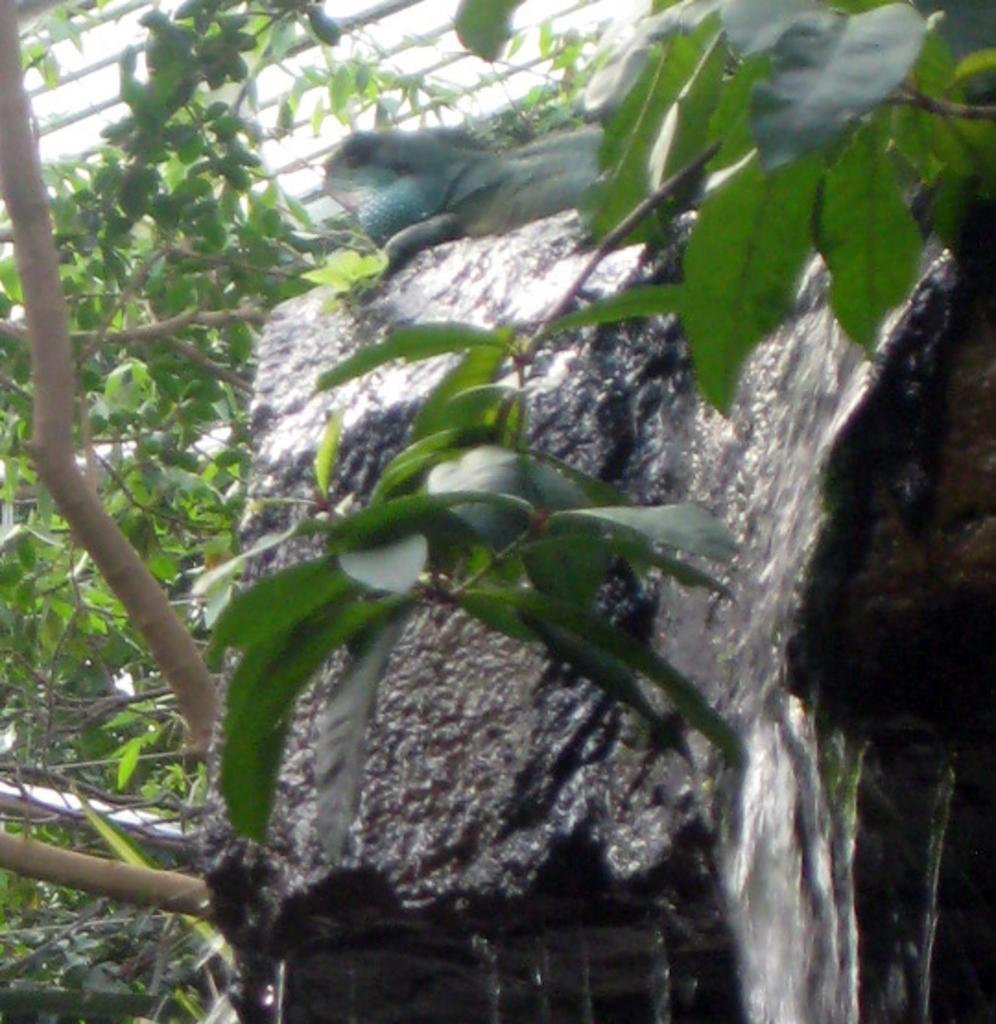Could you give a brief overview of what you see in this image? In this image I can see a reptile on a stone and water is passing through the stone. I can see some trees on the left side of the image and rods on the top of the image. 